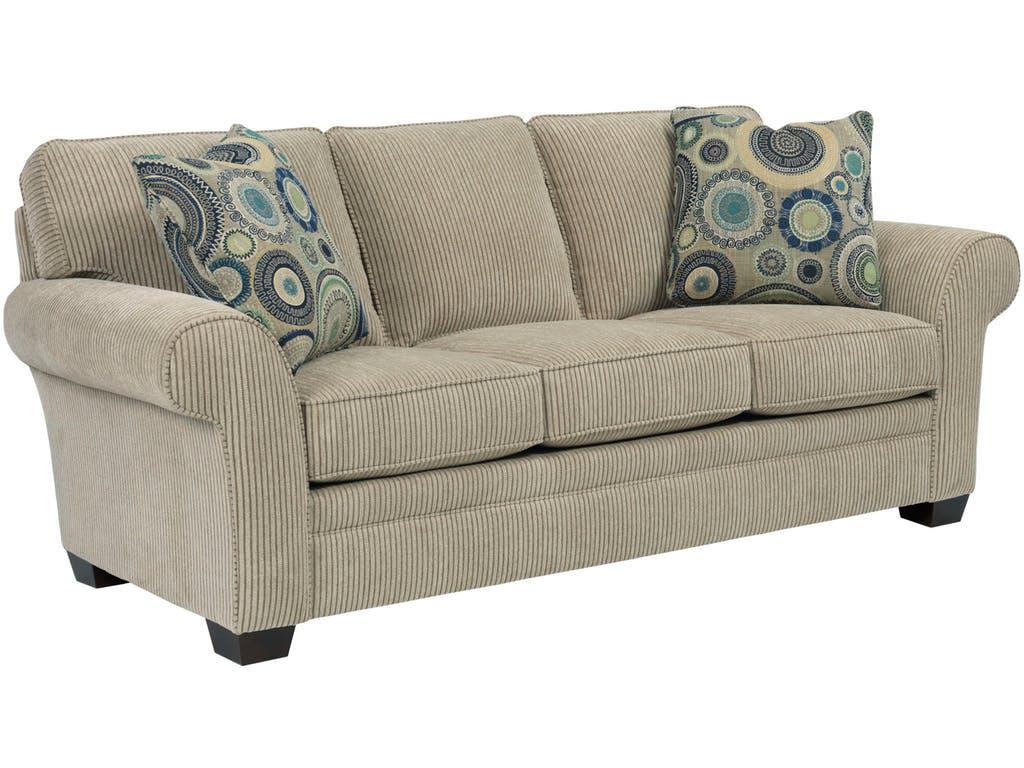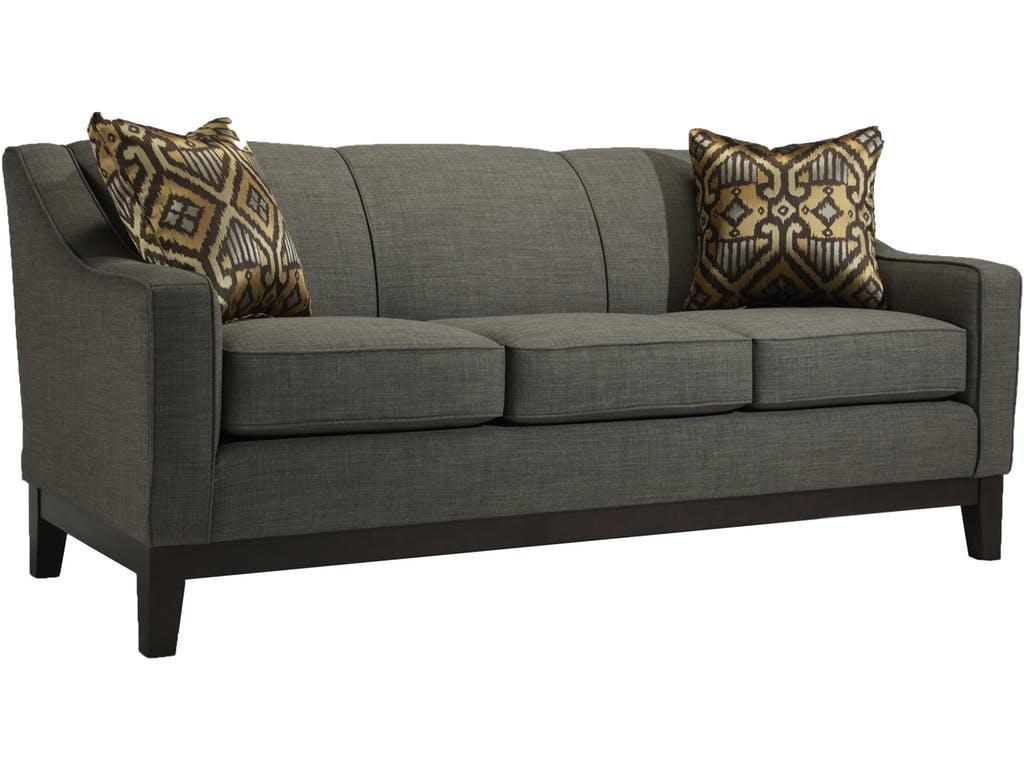The first image is the image on the left, the second image is the image on the right. Considering the images on both sides, is "There are two throw pillows with different color circle patterns sitting on top of a sofa." valid? Answer yes or no. Yes. The first image is the image on the left, the second image is the image on the right. Given the left and right images, does the statement "Each image features one diagonally-displayed three-cushion footed couch, with two matching patterned pillows positioned one on each end of the couch." hold true? Answer yes or no. Yes. 